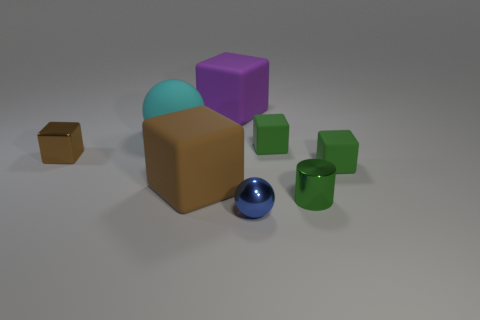Are there any big blocks that are behind the sphere that is behind the metal thing that is on the right side of the small sphere?
Provide a succinct answer. Yes. Does the blue sphere have the same material as the green cylinder?
Ensure brevity in your answer.  Yes. Are there any other things that have the same shape as the green shiny object?
Your answer should be very brief. No. There is a small object that is on the left side of the big purple matte cube right of the brown metal block; what is it made of?
Give a very brief answer. Metal. There is a sphere that is to the right of the purple matte cube; how big is it?
Provide a succinct answer. Small. There is a object that is left of the purple rubber thing and on the right side of the cyan sphere; what color is it?
Provide a succinct answer. Brown. There is a matte block that is behind the cyan rubber thing; does it have the same size as the tiny ball?
Your response must be concise. No. There is a tiny metallic object that is left of the metal sphere; is there a rubber thing behind it?
Offer a terse response. Yes. What is the material of the purple cube?
Ensure brevity in your answer.  Rubber. Are there any small things left of the purple matte cube?
Ensure brevity in your answer.  Yes. 